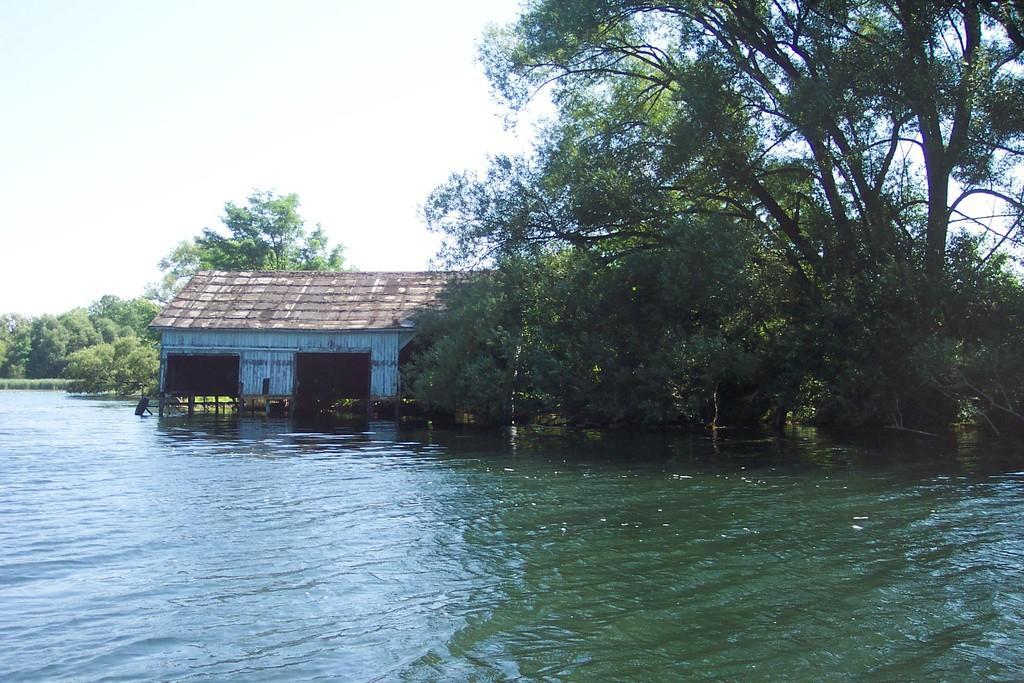What is in the foreground of the image? There is water in the foreground of the image. What can be seen in the background of the image? There are trees and a shed in the background of the image. What is visible above the trees and shed in the image? The sky is visible in the background of the image. What word is written on the shed in the image? There is no word written on the shed in the image. Can you see a beetle crawling on the trees in the image? There is no beetle present in the image. 